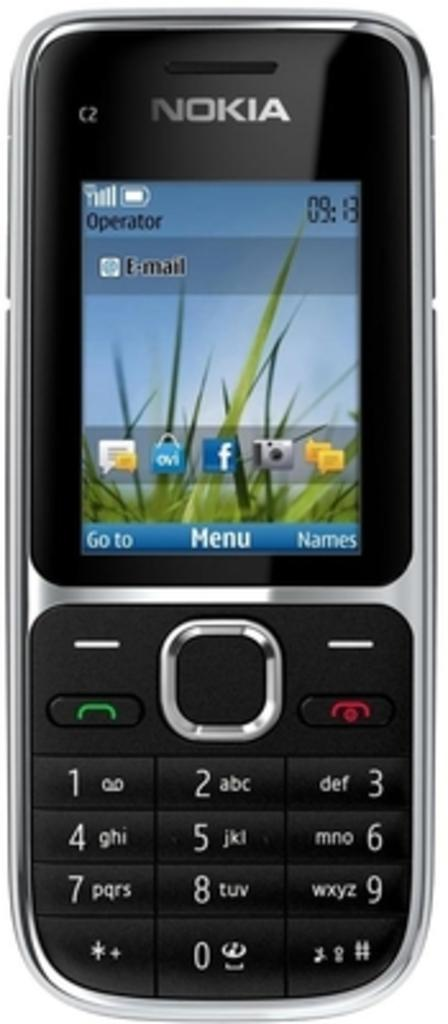<image>
Summarize the visual content of the image. A Nokia cell phone that displays a time of 9:13. 